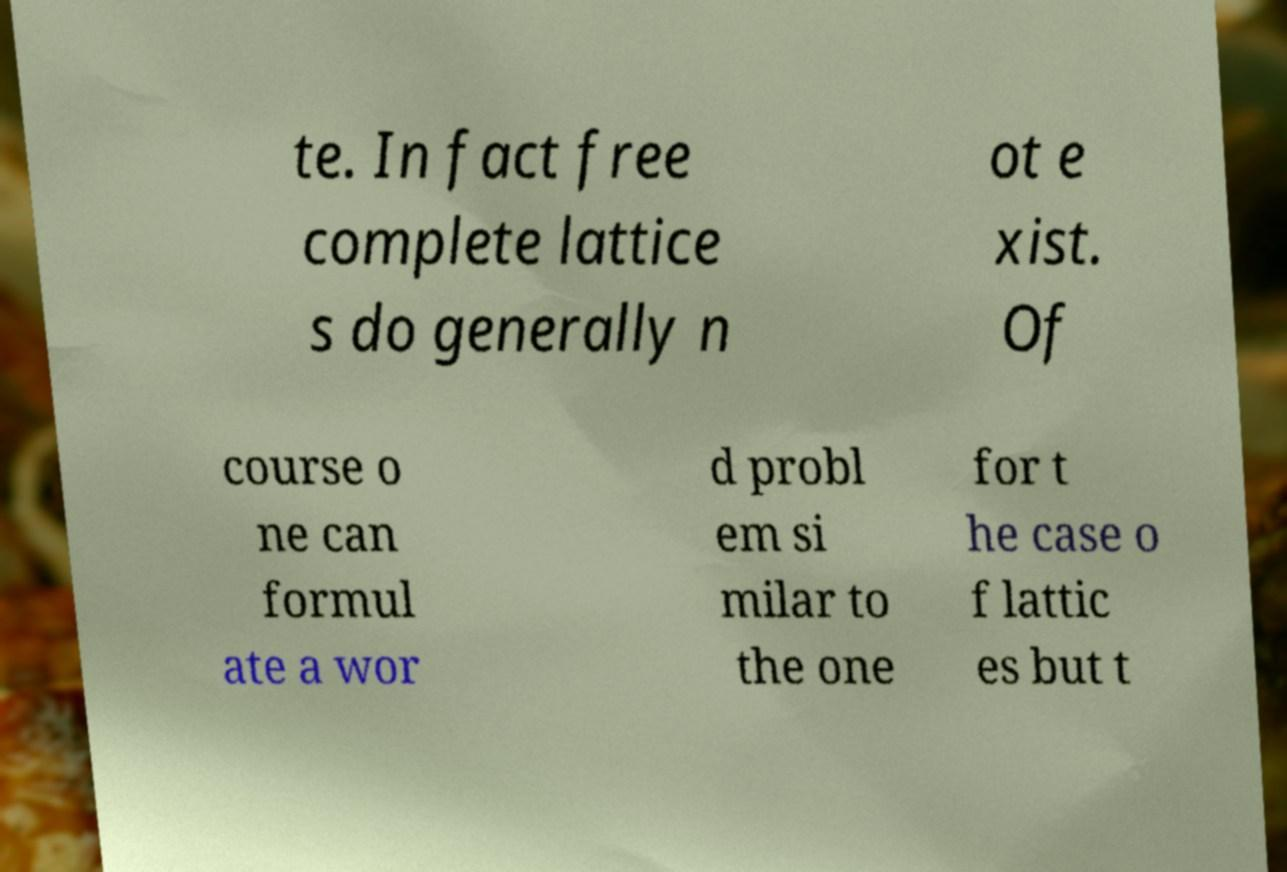Could you extract and type out the text from this image? te. In fact free complete lattice s do generally n ot e xist. Of course o ne can formul ate a wor d probl em si milar to the one for t he case o f lattic es but t 